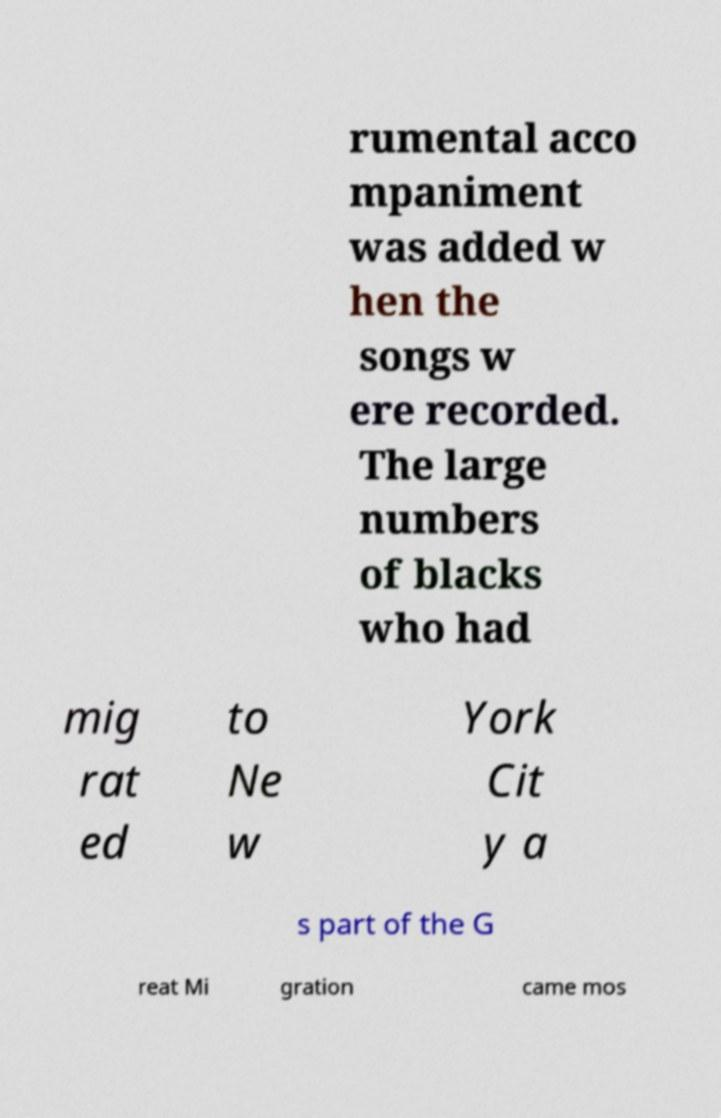Can you read and provide the text displayed in the image?This photo seems to have some interesting text. Can you extract and type it out for me? rumental acco mpaniment was added w hen the songs w ere recorded. The large numbers of blacks who had mig rat ed to Ne w York Cit y a s part of the G reat Mi gration came mos 